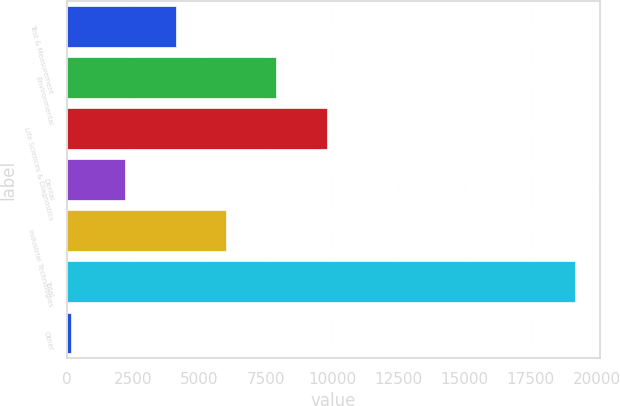<chart> <loc_0><loc_0><loc_500><loc_500><bar_chart><fcel>Test & Measurement<fcel>Environmental<fcel>Life Sciences & Diagnostics<fcel>Dental<fcel>Industrial Technologies<fcel>Total<fcel>Other<nl><fcel>4094.16<fcel>7896.28<fcel>9797.34<fcel>2193.1<fcel>5995.22<fcel>19154<fcel>143.4<nl></chart> 